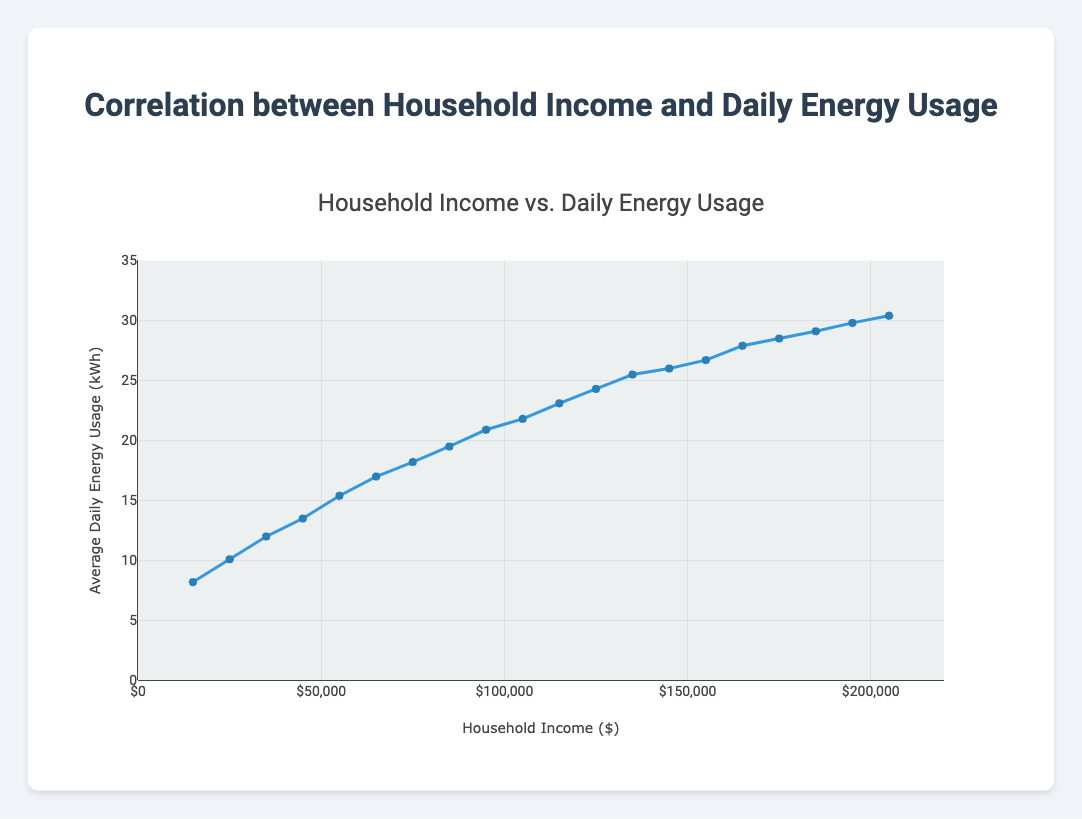What is the average daily energy usage for households with an income of $75,000? To answer this, locate the data point where the household income is $75,000 and look at the corresponding average daily energy usage value.
Answer: 18.2 kWh What is the difference in average daily energy usage between households earning $25,000 and those earning $195,000? Find the average daily energy usage for both income levels: $25,000 has 10.1 kWh and $195,000 has 29.8 kWh. Subtract the smaller value from the larger one.
Answer: 19.7 kWh By how much does the average daily energy usage increase when the household income increases from $35,000 to $85,000? For $35,000, the usage is 12.0 kWh; for $85,000, it is 19.5 kWh. Subtract the former from the latter.
Answer: 7.5 kWh At what income level does the average daily energy usage first exceed 20 kWh? Identify the data point where the average daily energy usage first becomes greater than 20 kWh.
Answer: $95,000 Which has a higher average daily energy usage: households earning $45,000 or those earning $145,000? Compare the average daily energy usage for $45,000 (13.5 kWh) and $145,000 (26.0 kWh).
Answer: $145,000 What is the visual representation of the data in terms of line and markers? The data is represented as a blue line with blue markers. Each marker corresponds to a data point with household income on the x-axis and average daily energy usage on the y-axis.
Answer: Blue line and markers What is the approximate slope of the line between household incomes $150,000 and $175,000? The average daily energy usage at $150,000 is 26.7 kWh, and at $175,000 it is 28.5 kWh. Calculate the slope: (28.5 - 26.7) / (175,000 - 150,000).
Answer: 0.072 kWh per $1,000 How does the average daily energy usage pattern change as household income increases from $65,000 to $85,000? Describe the trend between these income levels. At $65,000, the usage is 17.0 kWh and at $85,000, it is 19.5 kWh, showing a gradual increase in energy usage.
Answer: Gradual increase What is the range of average daily energy usage values depicted in the plot? Determine the minimum and maximum values of average daily energy usage in the data set. The minimum is 8.2 kWh (at $15,000) and the maximum is 30.4 kWh (at $205,000).
Answer: 8.2 kWh to 30.4 kWh How would you visually describe the curve’s trend? The curve shows an upward trend indicating that as household income increases, the average daily energy usage also increases.
Answer: Upward trend 